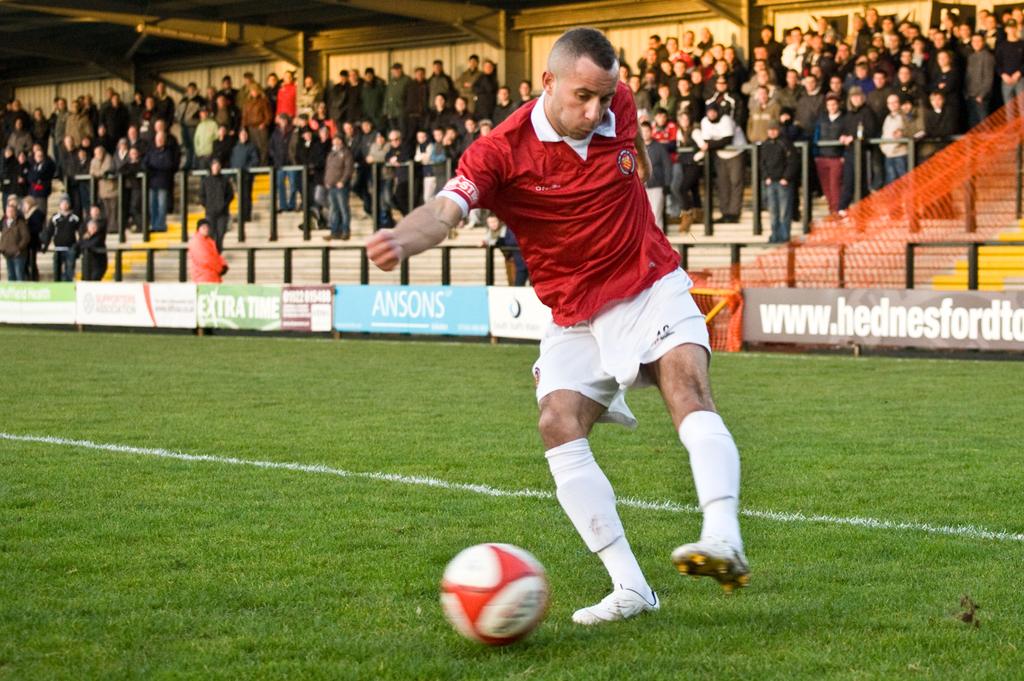What does the light blue sign say?
Give a very brief answer. Ansons. What is that website name?
Your response must be concise. Unanswerable. 